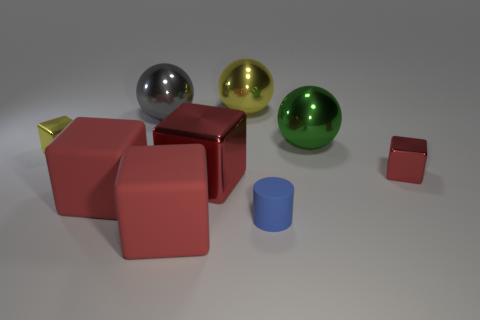Subtract all brown cylinders. How many red cubes are left? 4 Subtract all yellow metal blocks. How many blocks are left? 4 Subtract all yellow cubes. How many cubes are left? 4 Subtract all blue cubes. Subtract all blue spheres. How many cubes are left? 5 Add 1 green things. How many objects exist? 10 Subtract all balls. How many objects are left? 6 Subtract 0 cyan spheres. How many objects are left? 9 Subtract all small green metallic things. Subtract all green shiny things. How many objects are left? 8 Add 5 tiny shiny cubes. How many tiny shiny cubes are left? 7 Add 4 yellow metallic things. How many yellow metallic things exist? 6 